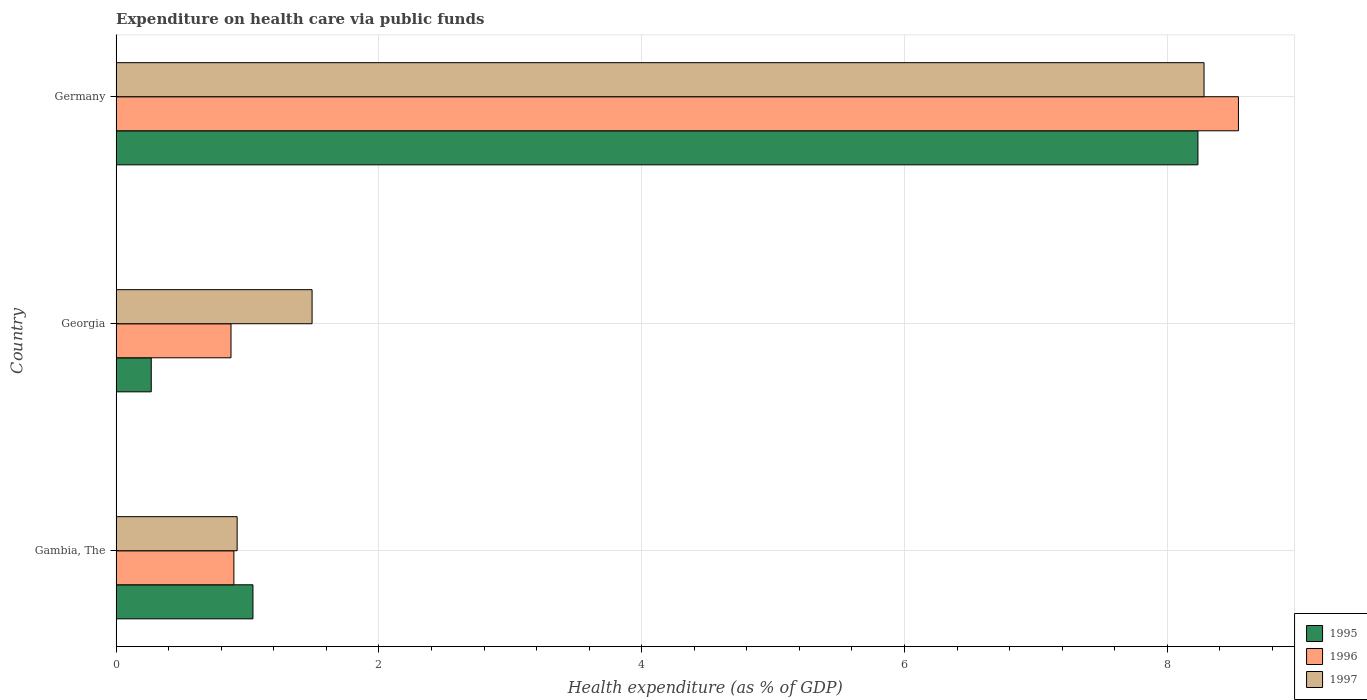How many different coloured bars are there?
Your answer should be very brief. 3. Are the number of bars per tick equal to the number of legend labels?
Offer a terse response. Yes. Are the number of bars on each tick of the Y-axis equal?
Your response must be concise. Yes. How many bars are there on the 3rd tick from the bottom?
Your response must be concise. 3. What is the label of the 3rd group of bars from the top?
Your answer should be very brief. Gambia, The. In how many cases, is the number of bars for a given country not equal to the number of legend labels?
Your response must be concise. 0. What is the expenditure made on health care in 1995 in Gambia, The?
Give a very brief answer. 1.04. Across all countries, what is the maximum expenditure made on health care in 1997?
Your answer should be compact. 8.28. Across all countries, what is the minimum expenditure made on health care in 1995?
Your response must be concise. 0.27. In which country was the expenditure made on health care in 1995 maximum?
Keep it short and to the point. Germany. In which country was the expenditure made on health care in 1995 minimum?
Offer a very short reply. Georgia. What is the total expenditure made on health care in 1996 in the graph?
Give a very brief answer. 10.31. What is the difference between the expenditure made on health care in 1995 in Georgia and that in Germany?
Ensure brevity in your answer.  -7.97. What is the difference between the expenditure made on health care in 1996 in Gambia, The and the expenditure made on health care in 1995 in Georgia?
Your response must be concise. 0.63. What is the average expenditure made on health care in 1995 per country?
Your answer should be compact. 3.18. What is the difference between the expenditure made on health care in 1995 and expenditure made on health care in 1997 in Germany?
Ensure brevity in your answer.  -0.05. In how many countries, is the expenditure made on health care in 1995 greater than 2 %?
Your response must be concise. 1. What is the ratio of the expenditure made on health care in 1995 in Georgia to that in Germany?
Provide a succinct answer. 0.03. Is the difference between the expenditure made on health care in 1995 in Georgia and Germany greater than the difference between the expenditure made on health care in 1997 in Georgia and Germany?
Give a very brief answer. No. What is the difference between the highest and the second highest expenditure made on health care in 1995?
Ensure brevity in your answer.  7.19. What is the difference between the highest and the lowest expenditure made on health care in 1995?
Provide a succinct answer. 7.97. In how many countries, is the expenditure made on health care in 1997 greater than the average expenditure made on health care in 1997 taken over all countries?
Ensure brevity in your answer.  1. Is the sum of the expenditure made on health care in 1995 in Gambia, The and Georgia greater than the maximum expenditure made on health care in 1997 across all countries?
Your answer should be very brief. No. What does the 3rd bar from the bottom in Georgia represents?
Keep it short and to the point. 1997. Are all the bars in the graph horizontal?
Make the answer very short. Yes. Are the values on the major ticks of X-axis written in scientific E-notation?
Make the answer very short. No. Where does the legend appear in the graph?
Give a very brief answer. Bottom right. How many legend labels are there?
Give a very brief answer. 3. How are the legend labels stacked?
Your answer should be compact. Vertical. What is the title of the graph?
Your answer should be compact. Expenditure on health care via public funds. Does "1964" appear as one of the legend labels in the graph?
Keep it short and to the point. No. What is the label or title of the X-axis?
Give a very brief answer. Health expenditure (as % of GDP). What is the Health expenditure (as % of GDP) of 1995 in Gambia, The?
Make the answer very short. 1.04. What is the Health expenditure (as % of GDP) of 1996 in Gambia, The?
Keep it short and to the point. 0.9. What is the Health expenditure (as % of GDP) in 1997 in Gambia, The?
Offer a very short reply. 0.92. What is the Health expenditure (as % of GDP) of 1995 in Georgia?
Make the answer very short. 0.27. What is the Health expenditure (as % of GDP) of 1996 in Georgia?
Ensure brevity in your answer.  0.87. What is the Health expenditure (as % of GDP) of 1997 in Georgia?
Give a very brief answer. 1.49. What is the Health expenditure (as % of GDP) in 1995 in Germany?
Provide a short and direct response. 8.23. What is the Health expenditure (as % of GDP) in 1996 in Germany?
Keep it short and to the point. 8.54. What is the Health expenditure (as % of GDP) of 1997 in Germany?
Provide a short and direct response. 8.28. Across all countries, what is the maximum Health expenditure (as % of GDP) of 1995?
Your response must be concise. 8.23. Across all countries, what is the maximum Health expenditure (as % of GDP) in 1996?
Make the answer very short. 8.54. Across all countries, what is the maximum Health expenditure (as % of GDP) of 1997?
Ensure brevity in your answer.  8.28. Across all countries, what is the minimum Health expenditure (as % of GDP) of 1995?
Provide a short and direct response. 0.27. Across all countries, what is the minimum Health expenditure (as % of GDP) in 1996?
Ensure brevity in your answer.  0.87. Across all countries, what is the minimum Health expenditure (as % of GDP) in 1997?
Ensure brevity in your answer.  0.92. What is the total Health expenditure (as % of GDP) in 1995 in the graph?
Keep it short and to the point. 9.54. What is the total Health expenditure (as % of GDP) of 1996 in the graph?
Make the answer very short. 10.31. What is the total Health expenditure (as % of GDP) of 1997 in the graph?
Provide a succinct answer. 10.69. What is the difference between the Health expenditure (as % of GDP) in 1995 in Gambia, The and that in Georgia?
Your response must be concise. 0.77. What is the difference between the Health expenditure (as % of GDP) in 1996 in Gambia, The and that in Georgia?
Ensure brevity in your answer.  0.02. What is the difference between the Health expenditure (as % of GDP) of 1997 in Gambia, The and that in Georgia?
Your answer should be very brief. -0.57. What is the difference between the Health expenditure (as % of GDP) in 1995 in Gambia, The and that in Germany?
Provide a succinct answer. -7.19. What is the difference between the Health expenditure (as % of GDP) of 1996 in Gambia, The and that in Germany?
Provide a succinct answer. -7.65. What is the difference between the Health expenditure (as % of GDP) of 1997 in Gambia, The and that in Germany?
Your answer should be very brief. -7.36. What is the difference between the Health expenditure (as % of GDP) in 1995 in Georgia and that in Germany?
Your response must be concise. -7.97. What is the difference between the Health expenditure (as % of GDP) in 1996 in Georgia and that in Germany?
Your response must be concise. -7.67. What is the difference between the Health expenditure (as % of GDP) of 1997 in Georgia and that in Germany?
Make the answer very short. -6.79. What is the difference between the Health expenditure (as % of GDP) of 1995 in Gambia, The and the Health expenditure (as % of GDP) of 1996 in Georgia?
Offer a very short reply. 0.17. What is the difference between the Health expenditure (as % of GDP) in 1995 in Gambia, The and the Health expenditure (as % of GDP) in 1997 in Georgia?
Keep it short and to the point. -0.45. What is the difference between the Health expenditure (as % of GDP) in 1996 in Gambia, The and the Health expenditure (as % of GDP) in 1997 in Georgia?
Provide a short and direct response. -0.6. What is the difference between the Health expenditure (as % of GDP) in 1995 in Gambia, The and the Health expenditure (as % of GDP) in 1996 in Germany?
Your answer should be compact. -7.5. What is the difference between the Health expenditure (as % of GDP) of 1995 in Gambia, The and the Health expenditure (as % of GDP) of 1997 in Germany?
Your answer should be very brief. -7.24. What is the difference between the Health expenditure (as % of GDP) in 1996 in Gambia, The and the Health expenditure (as % of GDP) in 1997 in Germany?
Your answer should be compact. -7.38. What is the difference between the Health expenditure (as % of GDP) of 1995 in Georgia and the Health expenditure (as % of GDP) of 1996 in Germany?
Offer a very short reply. -8.27. What is the difference between the Health expenditure (as % of GDP) of 1995 in Georgia and the Health expenditure (as % of GDP) of 1997 in Germany?
Your answer should be compact. -8.01. What is the difference between the Health expenditure (as % of GDP) in 1996 in Georgia and the Health expenditure (as % of GDP) in 1997 in Germany?
Make the answer very short. -7.41. What is the average Health expenditure (as % of GDP) in 1995 per country?
Your answer should be very brief. 3.18. What is the average Health expenditure (as % of GDP) of 1996 per country?
Your answer should be very brief. 3.44. What is the average Health expenditure (as % of GDP) in 1997 per country?
Provide a short and direct response. 3.56. What is the difference between the Health expenditure (as % of GDP) of 1995 and Health expenditure (as % of GDP) of 1996 in Gambia, The?
Provide a short and direct response. 0.15. What is the difference between the Health expenditure (as % of GDP) in 1995 and Health expenditure (as % of GDP) in 1997 in Gambia, The?
Give a very brief answer. 0.12. What is the difference between the Health expenditure (as % of GDP) in 1996 and Health expenditure (as % of GDP) in 1997 in Gambia, The?
Your answer should be compact. -0.02. What is the difference between the Health expenditure (as % of GDP) in 1995 and Health expenditure (as % of GDP) in 1996 in Georgia?
Your response must be concise. -0.61. What is the difference between the Health expenditure (as % of GDP) in 1995 and Health expenditure (as % of GDP) in 1997 in Georgia?
Provide a short and direct response. -1.22. What is the difference between the Health expenditure (as % of GDP) of 1996 and Health expenditure (as % of GDP) of 1997 in Georgia?
Offer a very short reply. -0.62. What is the difference between the Health expenditure (as % of GDP) in 1995 and Health expenditure (as % of GDP) in 1996 in Germany?
Keep it short and to the point. -0.31. What is the difference between the Health expenditure (as % of GDP) in 1995 and Health expenditure (as % of GDP) in 1997 in Germany?
Your answer should be very brief. -0.05. What is the difference between the Health expenditure (as % of GDP) in 1996 and Health expenditure (as % of GDP) in 1997 in Germany?
Your answer should be very brief. 0.26. What is the ratio of the Health expenditure (as % of GDP) of 1995 in Gambia, The to that in Georgia?
Give a very brief answer. 3.9. What is the ratio of the Health expenditure (as % of GDP) of 1996 in Gambia, The to that in Georgia?
Make the answer very short. 1.03. What is the ratio of the Health expenditure (as % of GDP) in 1997 in Gambia, The to that in Georgia?
Provide a short and direct response. 0.62. What is the ratio of the Health expenditure (as % of GDP) in 1995 in Gambia, The to that in Germany?
Make the answer very short. 0.13. What is the ratio of the Health expenditure (as % of GDP) in 1996 in Gambia, The to that in Germany?
Offer a very short reply. 0.1. What is the ratio of the Health expenditure (as % of GDP) in 1997 in Gambia, The to that in Germany?
Your response must be concise. 0.11. What is the ratio of the Health expenditure (as % of GDP) of 1995 in Georgia to that in Germany?
Give a very brief answer. 0.03. What is the ratio of the Health expenditure (as % of GDP) of 1996 in Georgia to that in Germany?
Provide a short and direct response. 0.1. What is the ratio of the Health expenditure (as % of GDP) of 1997 in Georgia to that in Germany?
Provide a short and direct response. 0.18. What is the difference between the highest and the second highest Health expenditure (as % of GDP) of 1995?
Make the answer very short. 7.19. What is the difference between the highest and the second highest Health expenditure (as % of GDP) of 1996?
Your answer should be compact. 7.65. What is the difference between the highest and the second highest Health expenditure (as % of GDP) of 1997?
Offer a terse response. 6.79. What is the difference between the highest and the lowest Health expenditure (as % of GDP) in 1995?
Provide a succinct answer. 7.97. What is the difference between the highest and the lowest Health expenditure (as % of GDP) in 1996?
Keep it short and to the point. 7.67. What is the difference between the highest and the lowest Health expenditure (as % of GDP) in 1997?
Ensure brevity in your answer.  7.36. 